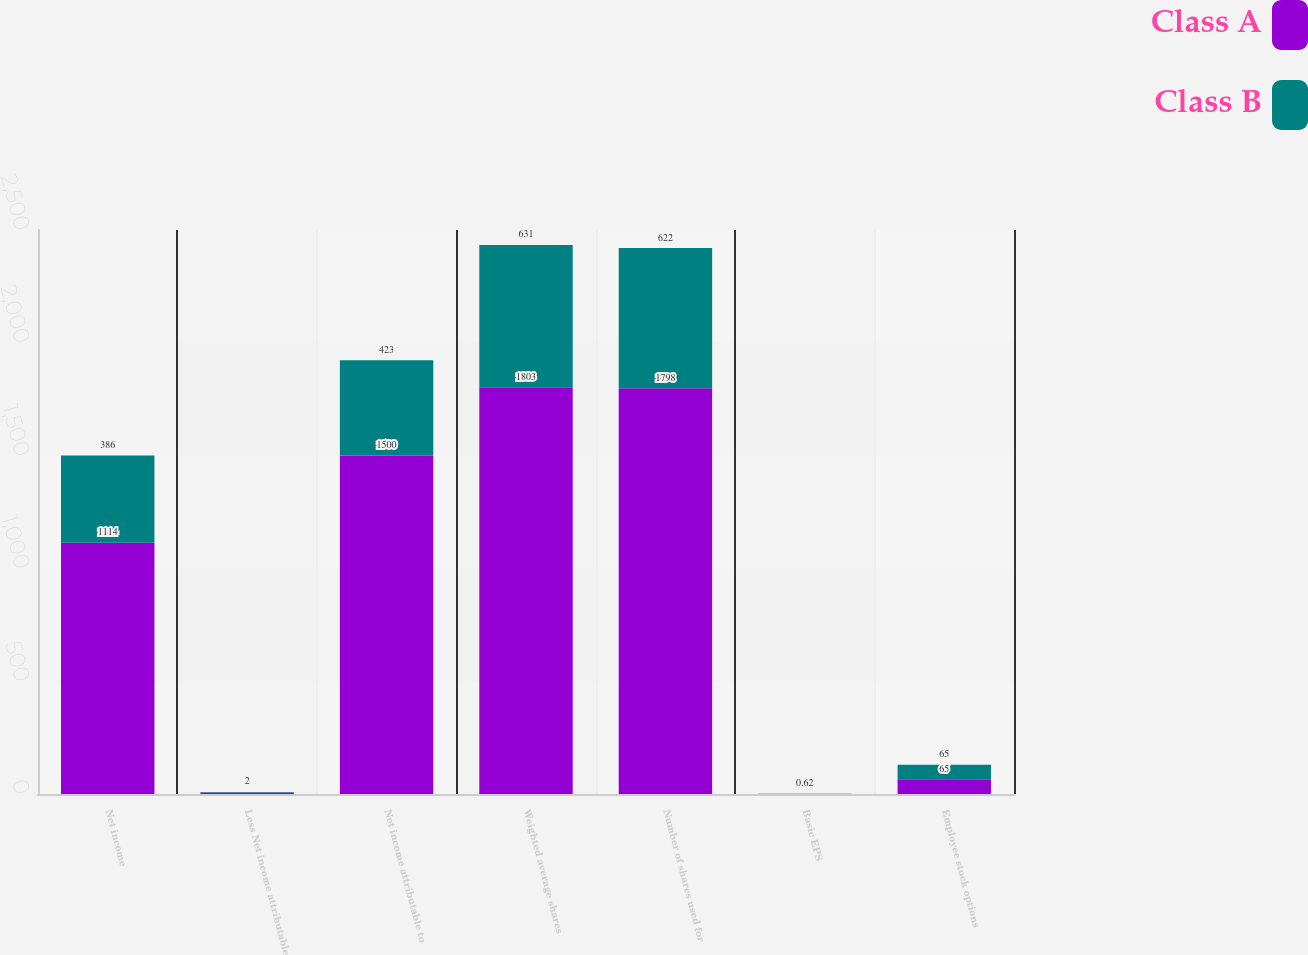Convert chart. <chart><loc_0><loc_0><loc_500><loc_500><stacked_bar_chart><ecel><fcel>Net income<fcel>Less Net income attributable<fcel>Net income attributable to<fcel>Weighted average shares<fcel>Number of shares used for<fcel>Basic EPS<fcel>Employee stock options<nl><fcel>Class A<fcel>1114<fcel>7<fcel>1500<fcel>1803<fcel>1798<fcel>0.62<fcel>65<nl><fcel>Class B<fcel>386<fcel>2<fcel>423<fcel>631<fcel>622<fcel>0.62<fcel>65<nl></chart> 